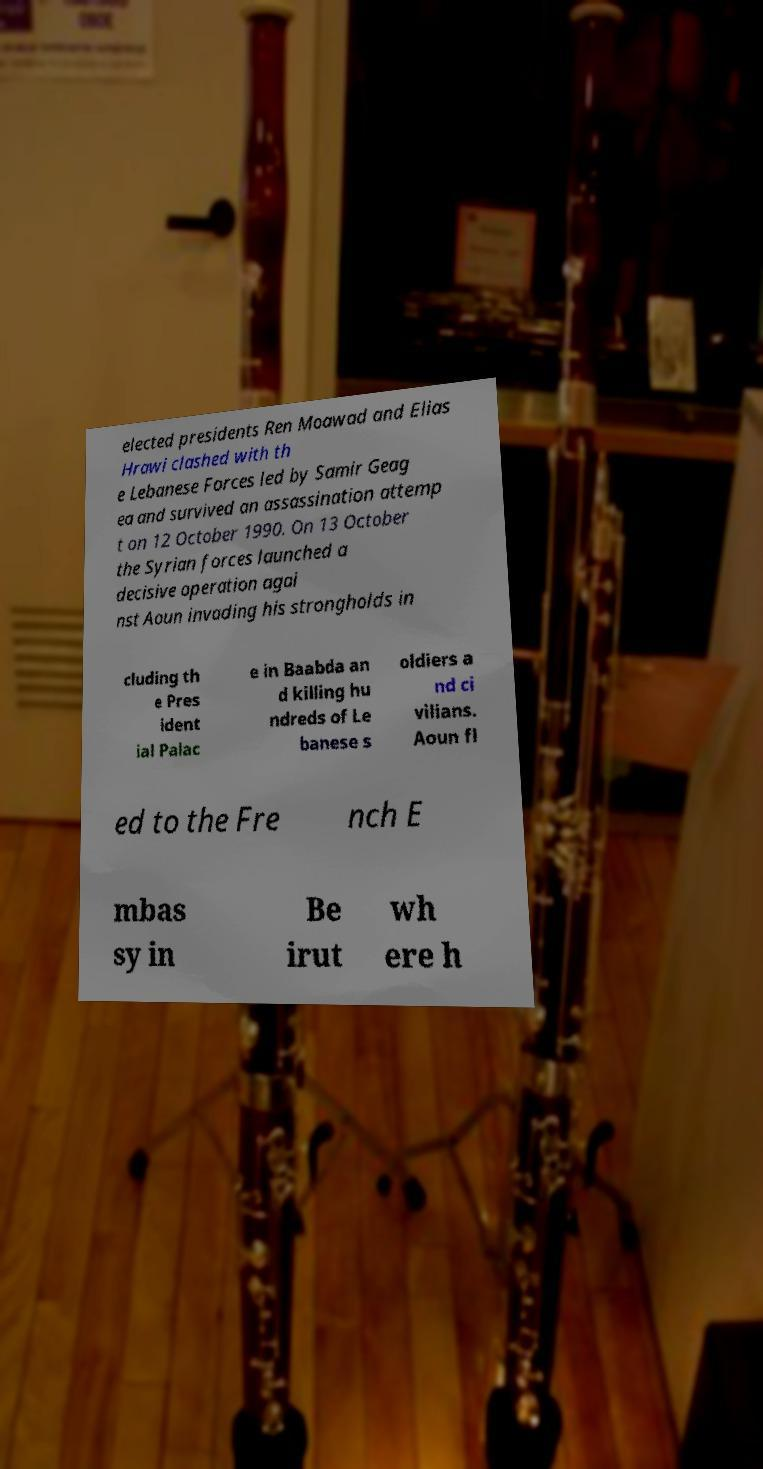For documentation purposes, I need the text within this image transcribed. Could you provide that? elected presidents Ren Moawad and Elias Hrawi clashed with th e Lebanese Forces led by Samir Geag ea and survived an assassination attemp t on 12 October 1990. On 13 October the Syrian forces launched a decisive operation agai nst Aoun invading his strongholds in cluding th e Pres ident ial Palac e in Baabda an d killing hu ndreds of Le banese s oldiers a nd ci vilians. Aoun fl ed to the Fre nch E mbas sy in Be irut wh ere h 